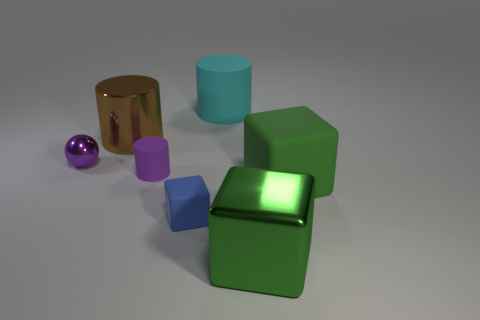How is the lighting affecting the appearance of the objects? The lighting in the image appears to be coming from the upper left side, casting soft shadows to the right of the objects. It enhances the reflective qualities of the metallic objects and creates highlights and shadows that give a three-dimensional quality to the shapes. 